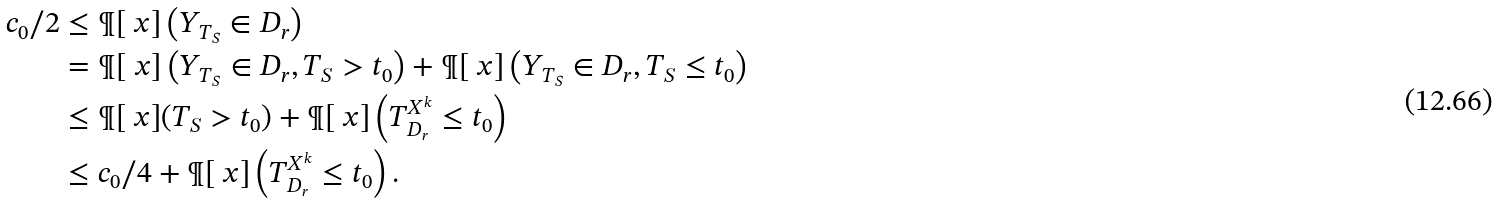<formula> <loc_0><loc_0><loc_500><loc_500>c _ { 0 } / 2 & \leq \P [ \ x ] \left ( Y _ { T _ { S } } \in D _ { r } \right ) \\ & = \P [ \ x ] \left ( Y _ { T _ { S } } \in D _ { r } , T _ { S } > t _ { 0 } \right ) + \P [ \ x ] \left ( Y _ { T _ { S } } \in D _ { r } , T _ { S } \leq t _ { 0 } \right ) \\ & \leq \P [ \ x ] ( T _ { S } > t _ { 0 } ) + \P [ \ x ] \left ( T ^ { X ^ { k } } _ { D _ { r } } \leq t _ { 0 } \right ) \\ & \leq c _ { 0 } / 4 + \P [ \ x ] \left ( T ^ { X ^ { k } } _ { D _ { r } } \leq t _ { 0 } \right ) .</formula> 